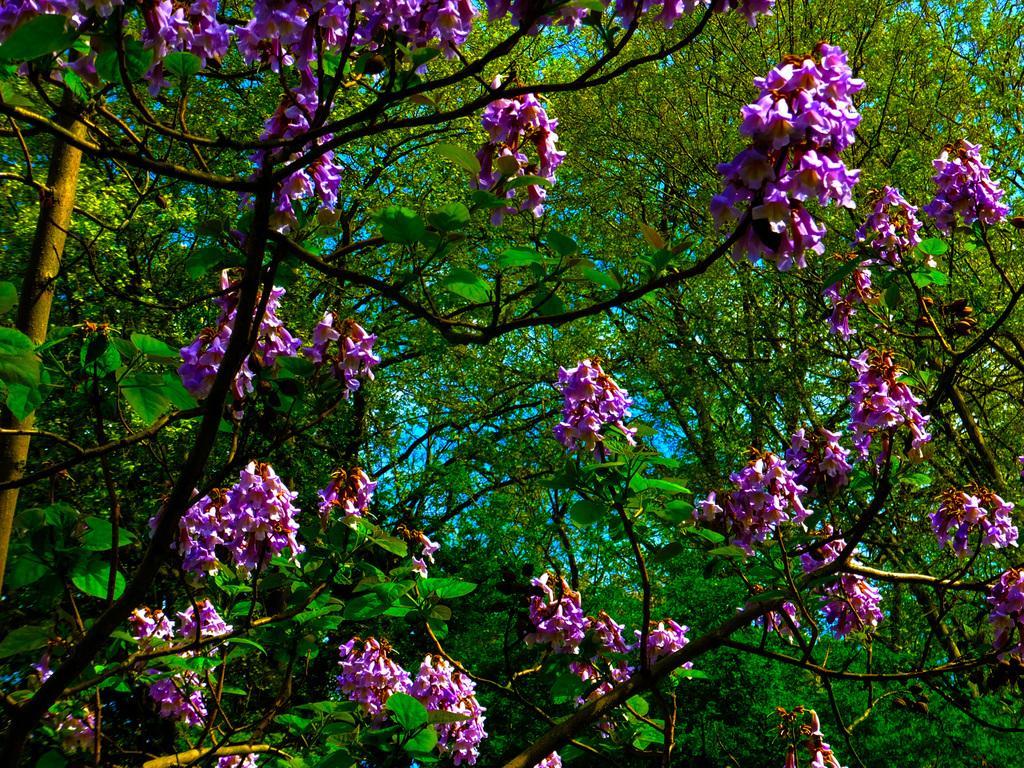How would you summarize this image in a sentence or two? In this image we can see tree with flowers. 